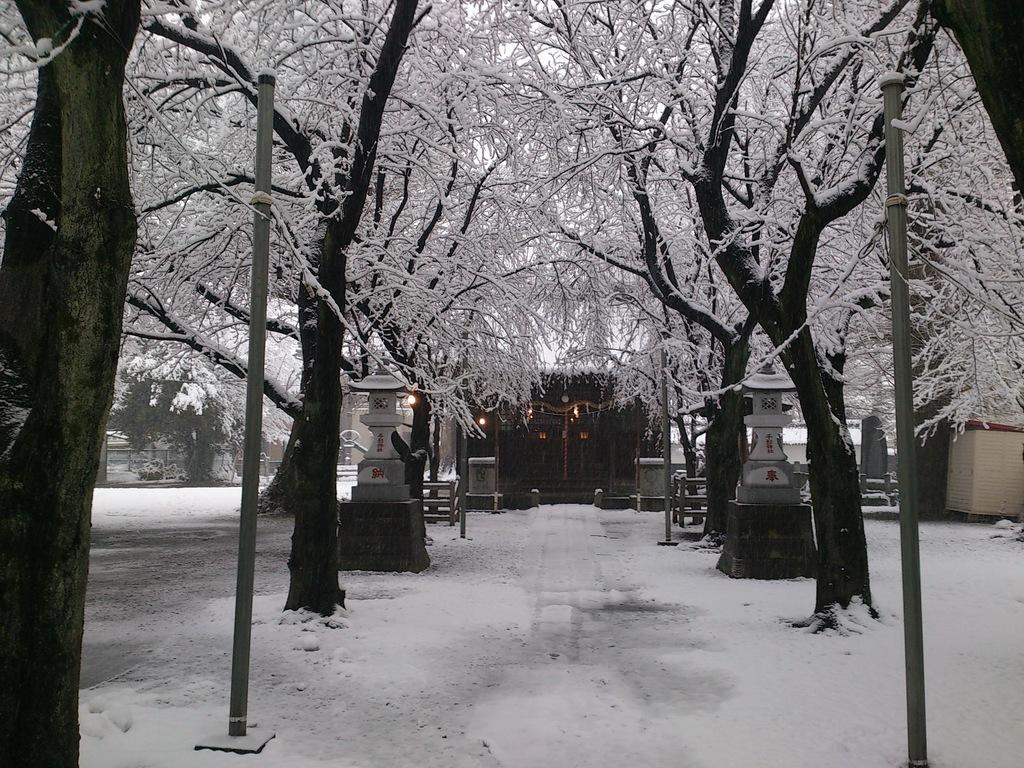What type of vegetation is present in the image? The image contains trees. What structure is located in the middle of the image? There is a house in the middle of the image. What is covering the ground at the bottom of the image? There is snow on the ground at the bottom of the image. What other building can be seen to the right of the image? There is a cabin to the right of the image. What type of shop can be seen in the image? There is no shop present in the image. What scent is associated with the truck in the image? There is no truck present in the image, so no scent can be associated with it. 